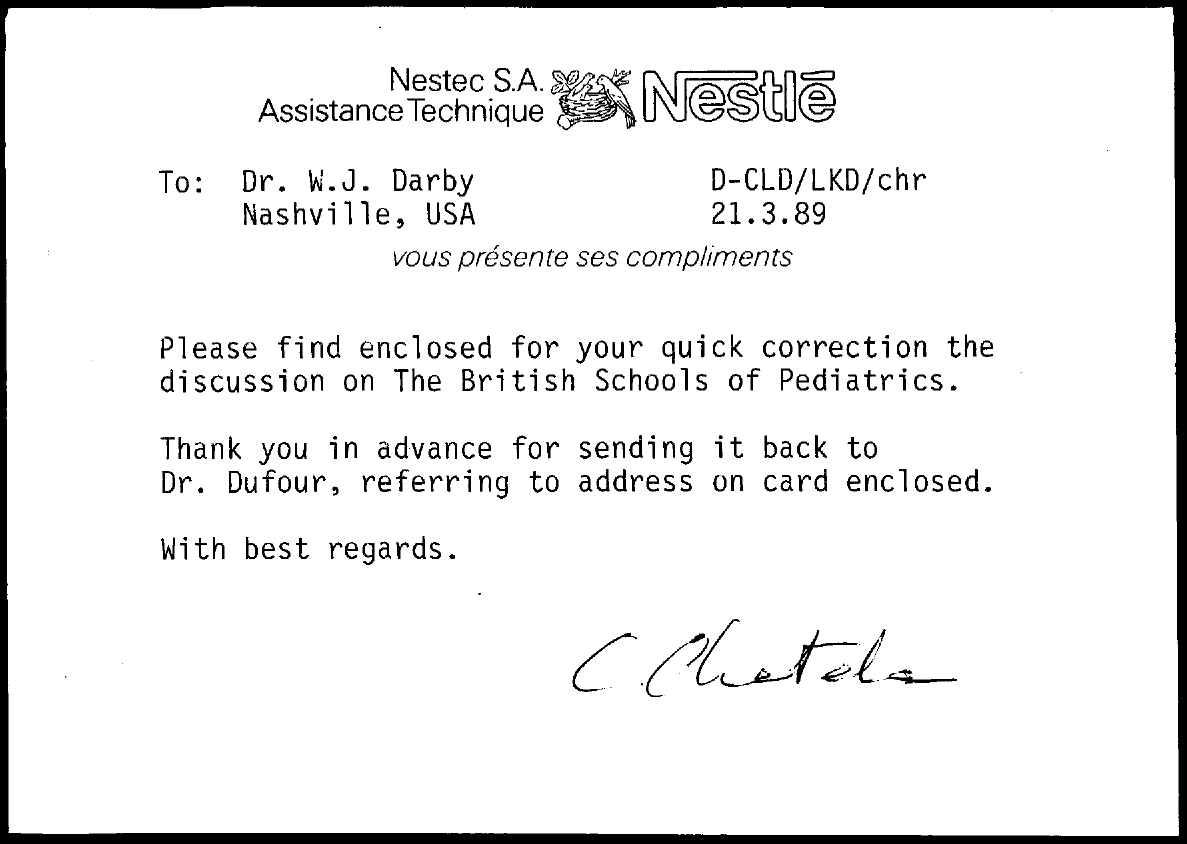What is the date mentioned in this letter?
Keep it short and to the point. 21.3.89. 